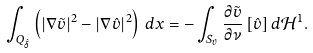<formula> <loc_0><loc_0><loc_500><loc_500>\int _ { Q _ { \hat { \delta } } } \left ( | \nabla \tilde { v } | ^ { 2 } - | \nabla \hat { v } | ^ { 2 } \right ) \, d x = - \int _ { S _ { \hat { v } } } \frac { \partial \tilde { v } } { \partial \nu } \, [ \hat { v } ] \, d \mathcal { H } ^ { 1 } .</formula> 